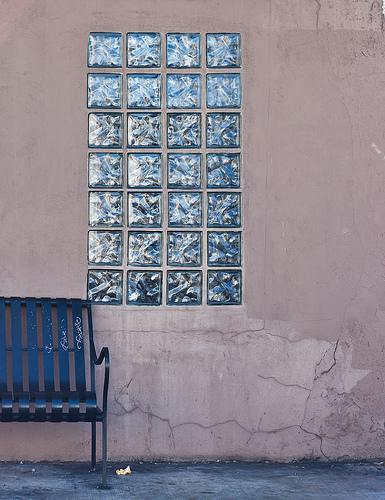Question: what color is the wall?
Choices:
A. White.
B. Brown.
C. Blue.
D. Beige.
Answer with the letter. Answer: D Question: why can't you see through the window?
Choices:
A. Shade is drawn.
B. Heaving tinting.
C. Wrong type of glass.
D. Stained glass.
Answer with the letter. Answer: C Question: how is this picture lit?
Choices:
A. Recessed lighting.
B. Spotlight.
C. It is not lit.
D. Natural light.
Answer with the letter. Answer: D 